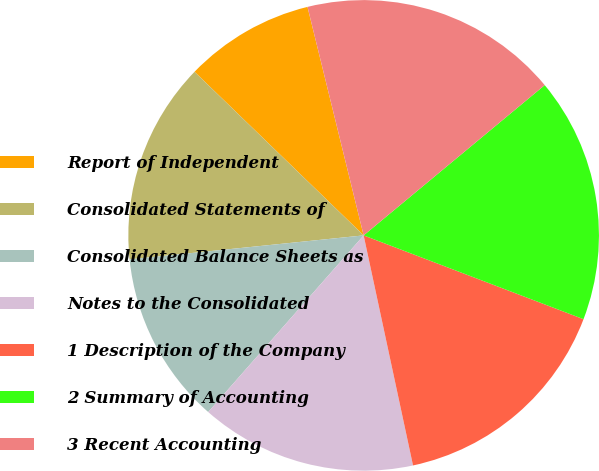Convert chart. <chart><loc_0><loc_0><loc_500><loc_500><pie_chart><fcel>Report of Independent<fcel>Consolidated Statements of<fcel>Consolidated Balance Sheets as<fcel>Notes to the Consolidated<fcel>1 Description of the Company<fcel>2 Summary of Accounting<fcel>3 Recent Accounting<nl><fcel>8.93%<fcel>13.86%<fcel>11.89%<fcel>14.85%<fcel>15.84%<fcel>16.82%<fcel>17.81%<nl></chart> 